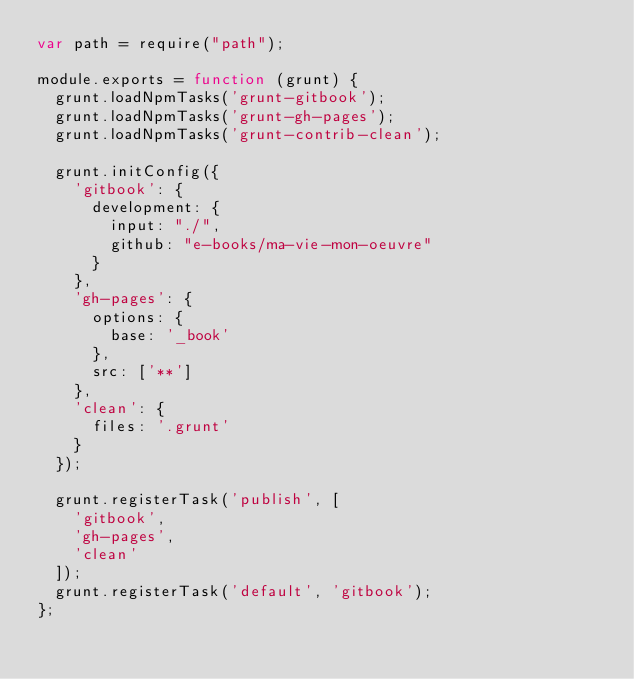<code> <loc_0><loc_0><loc_500><loc_500><_JavaScript_>var path = require("path");

module.exports = function (grunt) {
  grunt.loadNpmTasks('grunt-gitbook');
  grunt.loadNpmTasks('grunt-gh-pages');
  grunt.loadNpmTasks('grunt-contrib-clean');

  grunt.initConfig({
    'gitbook': {
      development: {
        input: "./",
        github: "e-books/ma-vie-mon-oeuvre"
      }
    },
    'gh-pages': {
      options: {
        base: '_book'
      },
      src: ['**']
    },
    'clean': {
      files: '.grunt'
    }
  });

  grunt.registerTask('publish', [
    'gitbook',
    'gh-pages',
    'clean'
  ]);
  grunt.registerTask('default', 'gitbook');
};</code> 